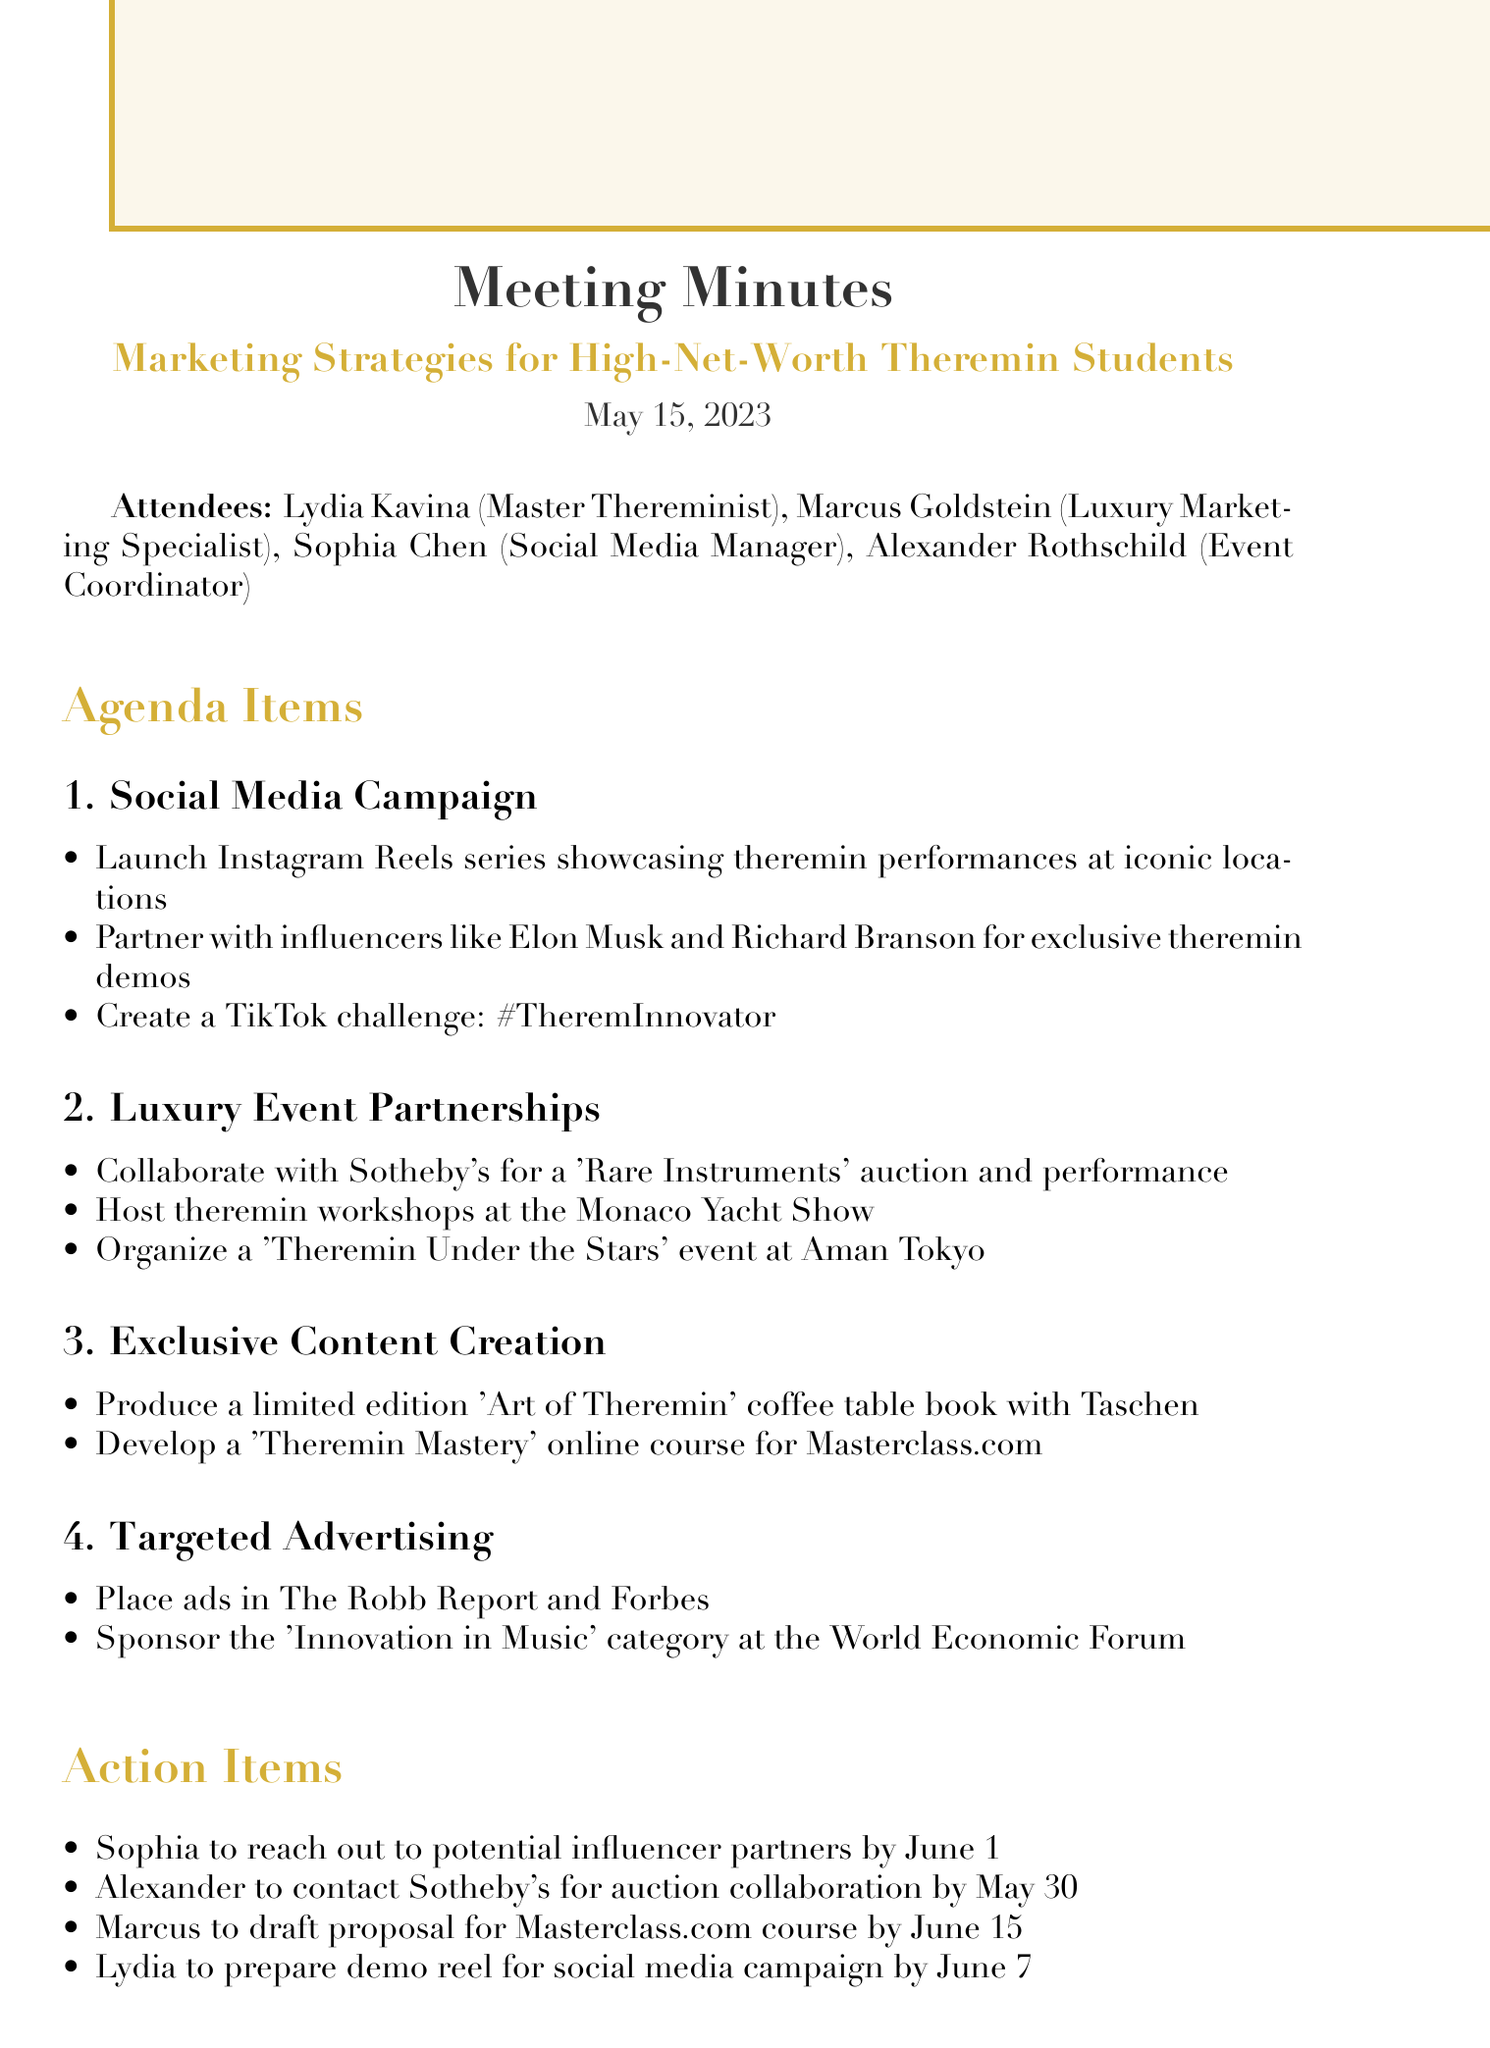what is the date of the meeting? The date of the meeting is explicitly mentioned at the beginning of the document.
Answer: May 15, 2023 who is the Master Thereminist present? The document lists Lydia Kavina as the Master Thereminist among the attendees.
Answer: Lydia Kavina what is one of the social media campaigns proposed? The document outlines specific points in the social media campaign section.
Answer: Launch Instagram Reels series which publication will ads be placed in? The targeted advertising section mentions specific publications for placing ads.
Answer: The Robb Report what is one action item for Sophia? The action items list specific responsibilities assigned to attendees.
Answer: Reach out to potential influencer partners by June 1 how many agenda items are there? The agenda comprises a list of topics discussed in the meeting.
Answer: Four in which luxury event will theremin workshops be hosted? The luxury event partnerships mention specific events for hosting workshops.
Answer: Monaco Yacht Show who is responsible for contacting Sotheby's? The action items detail who will accomplish various tasks following the meeting.
Answer: Alexander what is the title of the online course to be developed? The exclusive content creation section describes specific content to be created.
Answer: Theremin Mastery online course 